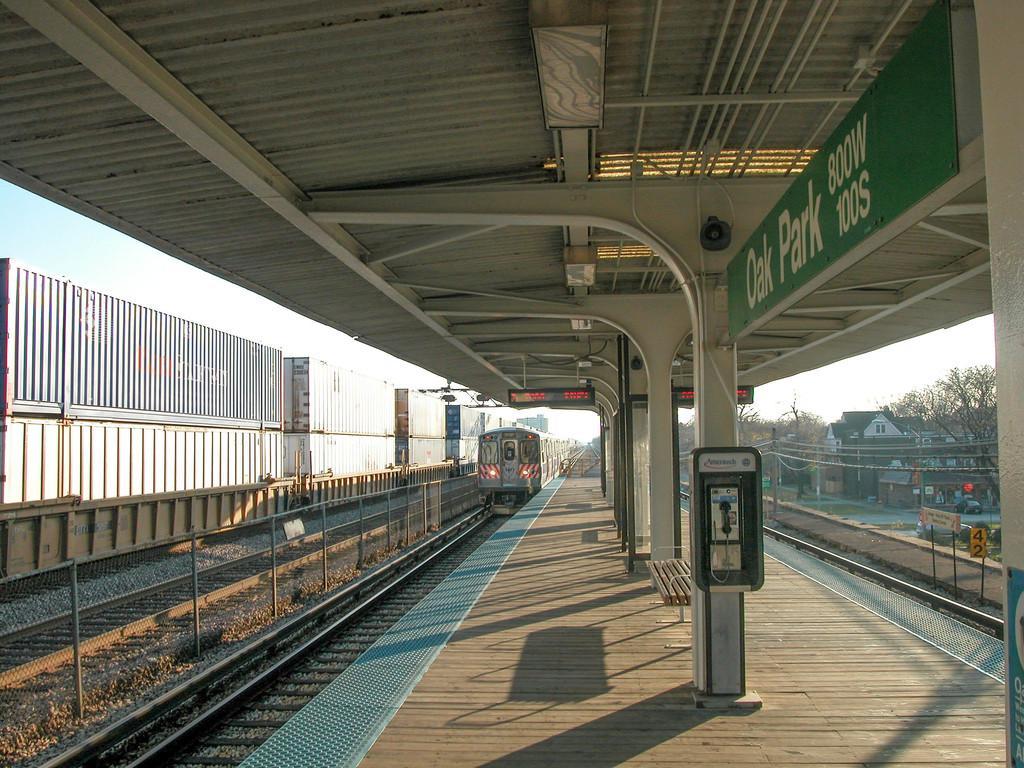Please provide a concise description of this image. In this picture I can see there is a train moving on the train and there is a platform here and on the right side and I can see there are buildings and trees and the sky is clear. 